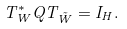Convert formula to latex. <formula><loc_0><loc_0><loc_500><loc_500>T ^ { * } _ { W } Q T _ { \tilde { W } } = I _ { H } .</formula> 